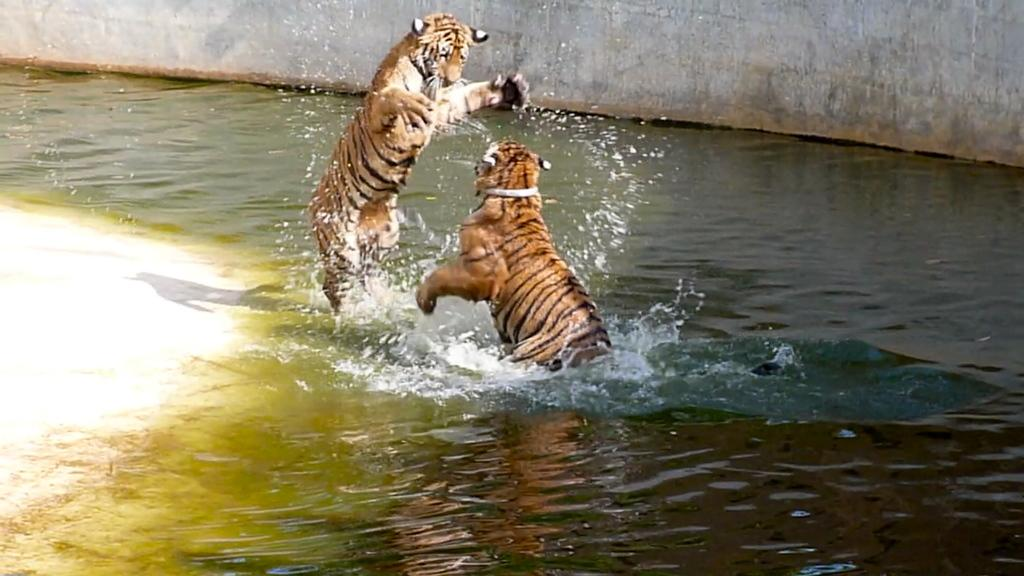What animals can be seen in the water in the image? There are two tigers in the water. What is visible in the background of the image? There is a wall in the background of the image. Where are the kittens hiding in the image? There are no kittens present in the image. 